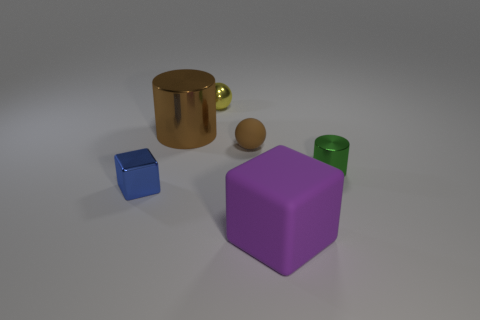What is the shape of the tiny matte object? The tiny matte object appears to be a small sphere. It's a simple three-dimensional shape that is perfectly symmetrical around its center, with every point on its surface lying the same distance from the center point. 